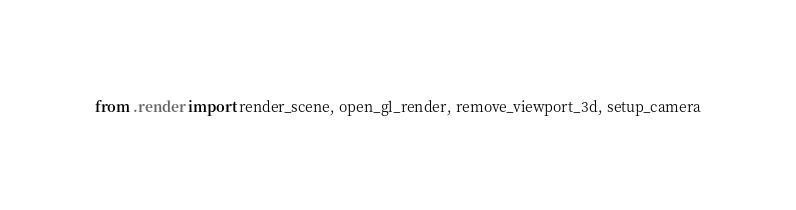<code> <loc_0><loc_0><loc_500><loc_500><_Python_>from .render import render_scene, open_gl_render, remove_viewport_3d, setup_camera
</code> 